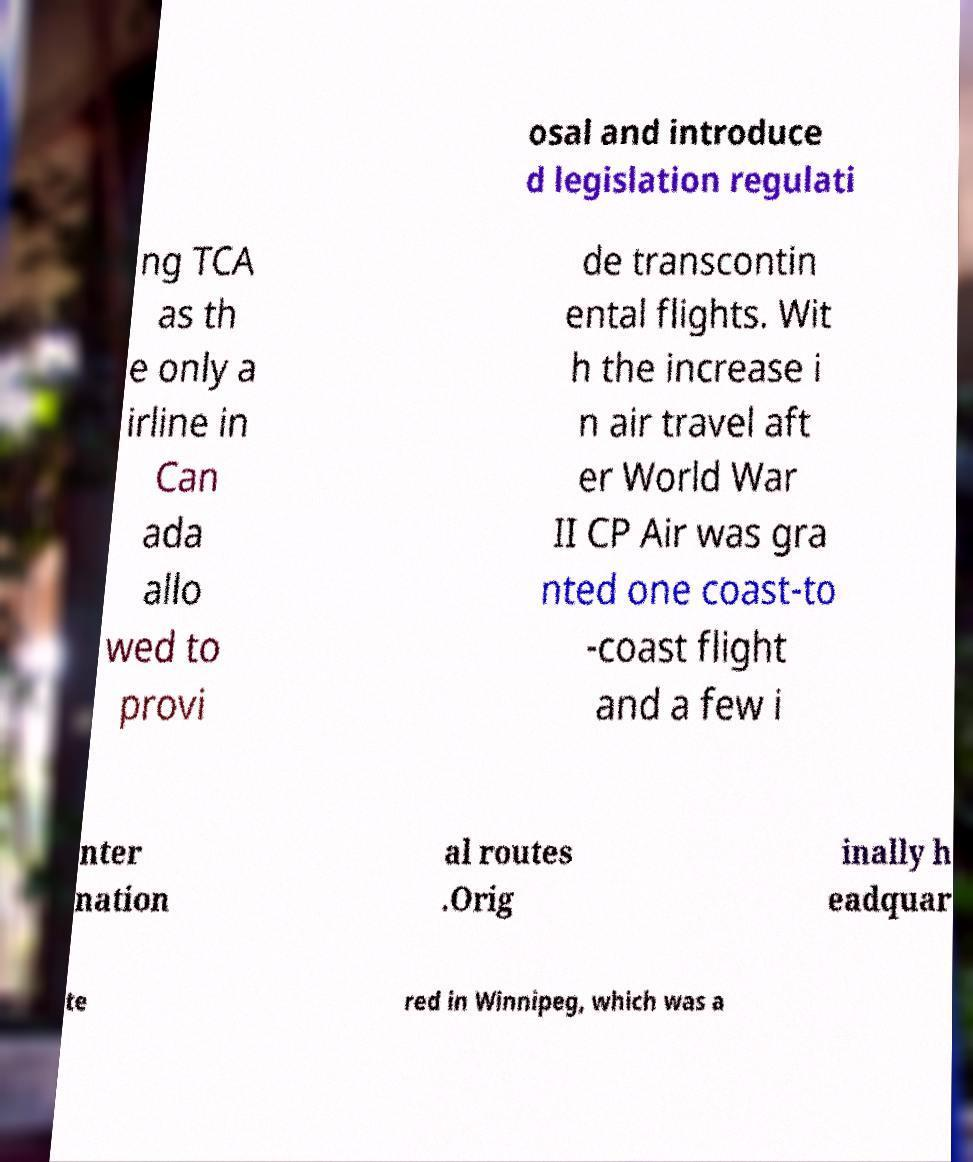For documentation purposes, I need the text within this image transcribed. Could you provide that? osal and introduce d legislation regulati ng TCA as th e only a irline in Can ada allo wed to provi de transcontin ental flights. Wit h the increase i n air travel aft er World War II CP Air was gra nted one coast-to -coast flight and a few i nter nation al routes .Orig inally h eadquar te red in Winnipeg, which was a 